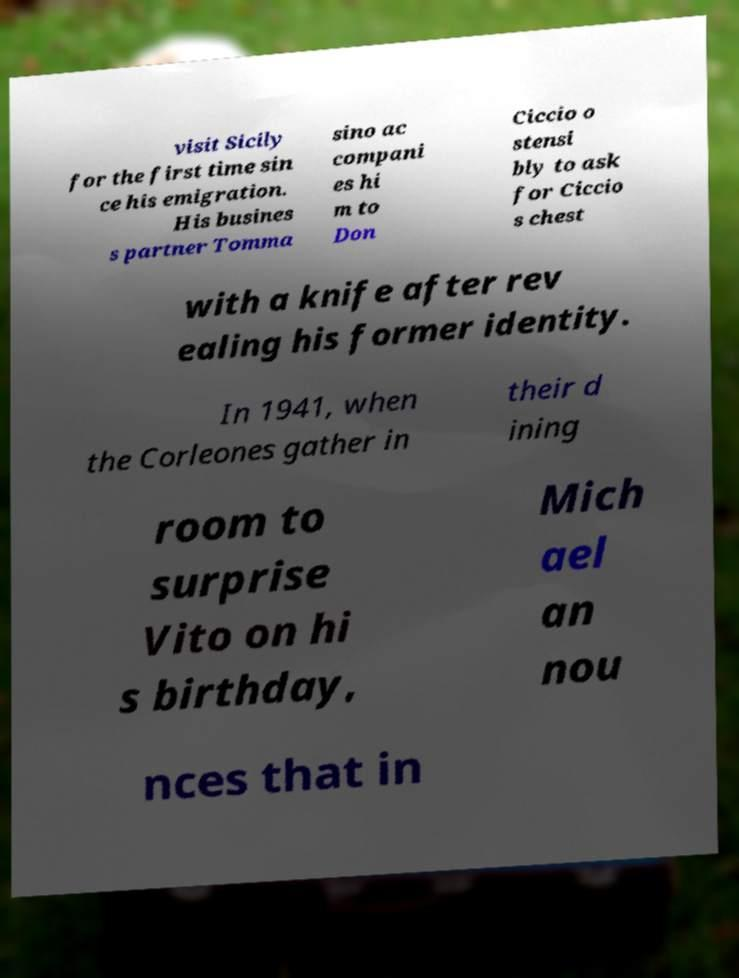Please read and relay the text visible in this image. What does it say? visit Sicily for the first time sin ce his emigration. His busines s partner Tomma sino ac compani es hi m to Don Ciccio o stensi bly to ask for Ciccio s chest with a knife after rev ealing his former identity. In 1941, when the Corleones gather in their d ining room to surprise Vito on hi s birthday, Mich ael an nou nces that in 